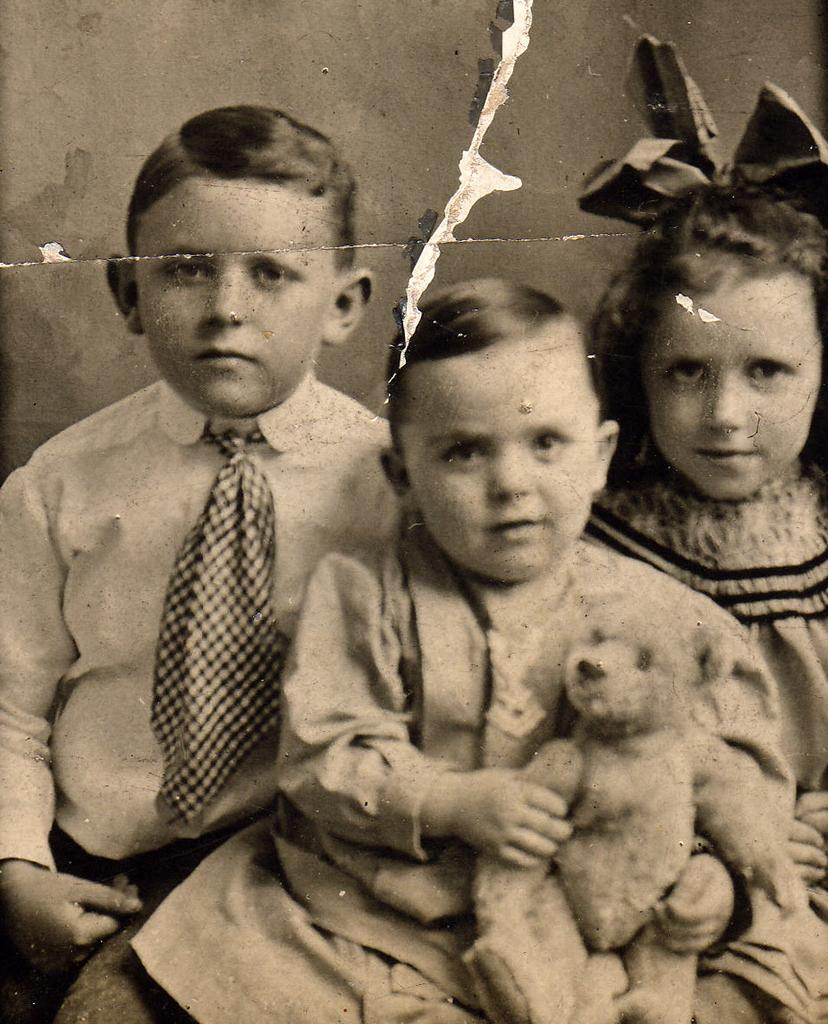How many children are in the image? There are three children in the image. What can be observed about the children's clothing? The children are wearing different color dresses. What is the facial expression of the children? The children are smiling. What are the children doing in the image? The children are sitting. What object is one of the children holding? One of the children is holding a doll. What can be seen in the background of the image? There is a wall in the background of the image. What type of form can be seen on the wall in the image? There is no form visible on the wall in the image. What story is being told by the children in the image? The image does not depict a story; it simply shows three children sitting and smiling. 